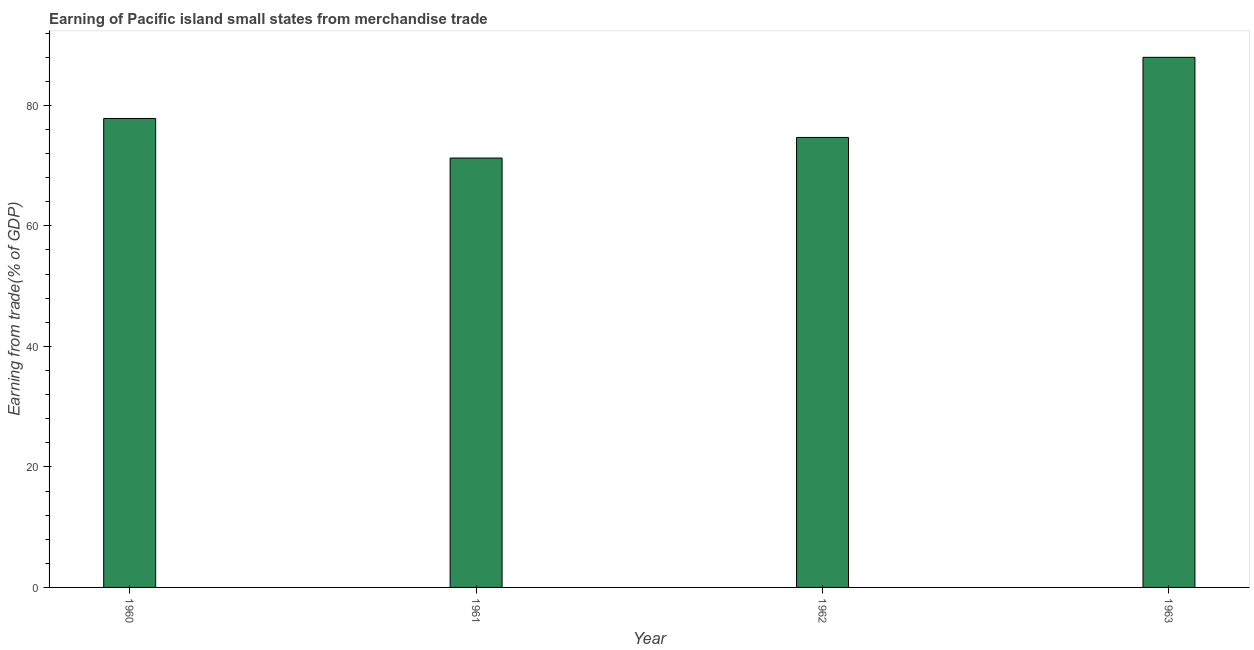Does the graph contain grids?
Offer a very short reply. No. What is the title of the graph?
Your answer should be compact. Earning of Pacific island small states from merchandise trade. What is the label or title of the X-axis?
Your response must be concise. Year. What is the label or title of the Y-axis?
Your answer should be compact. Earning from trade(% of GDP). What is the earning from merchandise trade in 1960?
Provide a short and direct response. 77.82. Across all years, what is the maximum earning from merchandise trade?
Your answer should be very brief. 87.96. Across all years, what is the minimum earning from merchandise trade?
Make the answer very short. 71.25. In which year was the earning from merchandise trade maximum?
Ensure brevity in your answer.  1963. In which year was the earning from merchandise trade minimum?
Your answer should be very brief. 1961. What is the sum of the earning from merchandise trade?
Make the answer very short. 311.7. What is the difference between the earning from merchandise trade in 1960 and 1961?
Your response must be concise. 6.57. What is the average earning from merchandise trade per year?
Provide a succinct answer. 77.93. What is the median earning from merchandise trade?
Ensure brevity in your answer.  76.24. Do a majority of the years between 1961 and 1963 (inclusive) have earning from merchandise trade greater than 84 %?
Offer a very short reply. No. What is the ratio of the earning from merchandise trade in 1961 to that in 1963?
Ensure brevity in your answer.  0.81. Is the earning from merchandise trade in 1962 less than that in 1963?
Give a very brief answer. Yes. What is the difference between the highest and the second highest earning from merchandise trade?
Offer a terse response. 10.14. Is the sum of the earning from merchandise trade in 1961 and 1962 greater than the maximum earning from merchandise trade across all years?
Your answer should be compact. Yes. What is the difference between the highest and the lowest earning from merchandise trade?
Your answer should be very brief. 16.71. In how many years, is the earning from merchandise trade greater than the average earning from merchandise trade taken over all years?
Provide a short and direct response. 1. What is the difference between two consecutive major ticks on the Y-axis?
Offer a terse response. 20. What is the Earning from trade(% of GDP) of 1960?
Give a very brief answer. 77.82. What is the Earning from trade(% of GDP) of 1961?
Provide a short and direct response. 71.25. What is the Earning from trade(% of GDP) in 1962?
Give a very brief answer. 74.67. What is the Earning from trade(% of GDP) in 1963?
Make the answer very short. 87.96. What is the difference between the Earning from trade(% of GDP) in 1960 and 1961?
Your answer should be compact. 6.57. What is the difference between the Earning from trade(% of GDP) in 1960 and 1962?
Your response must be concise. 3.15. What is the difference between the Earning from trade(% of GDP) in 1960 and 1963?
Offer a very short reply. -10.14. What is the difference between the Earning from trade(% of GDP) in 1961 and 1962?
Provide a short and direct response. -3.42. What is the difference between the Earning from trade(% of GDP) in 1961 and 1963?
Provide a succinct answer. -16.71. What is the difference between the Earning from trade(% of GDP) in 1962 and 1963?
Your response must be concise. -13.3. What is the ratio of the Earning from trade(% of GDP) in 1960 to that in 1961?
Your answer should be very brief. 1.09. What is the ratio of the Earning from trade(% of GDP) in 1960 to that in 1962?
Your answer should be very brief. 1.04. What is the ratio of the Earning from trade(% of GDP) in 1960 to that in 1963?
Keep it short and to the point. 0.89. What is the ratio of the Earning from trade(% of GDP) in 1961 to that in 1962?
Give a very brief answer. 0.95. What is the ratio of the Earning from trade(% of GDP) in 1961 to that in 1963?
Make the answer very short. 0.81. What is the ratio of the Earning from trade(% of GDP) in 1962 to that in 1963?
Your answer should be very brief. 0.85. 